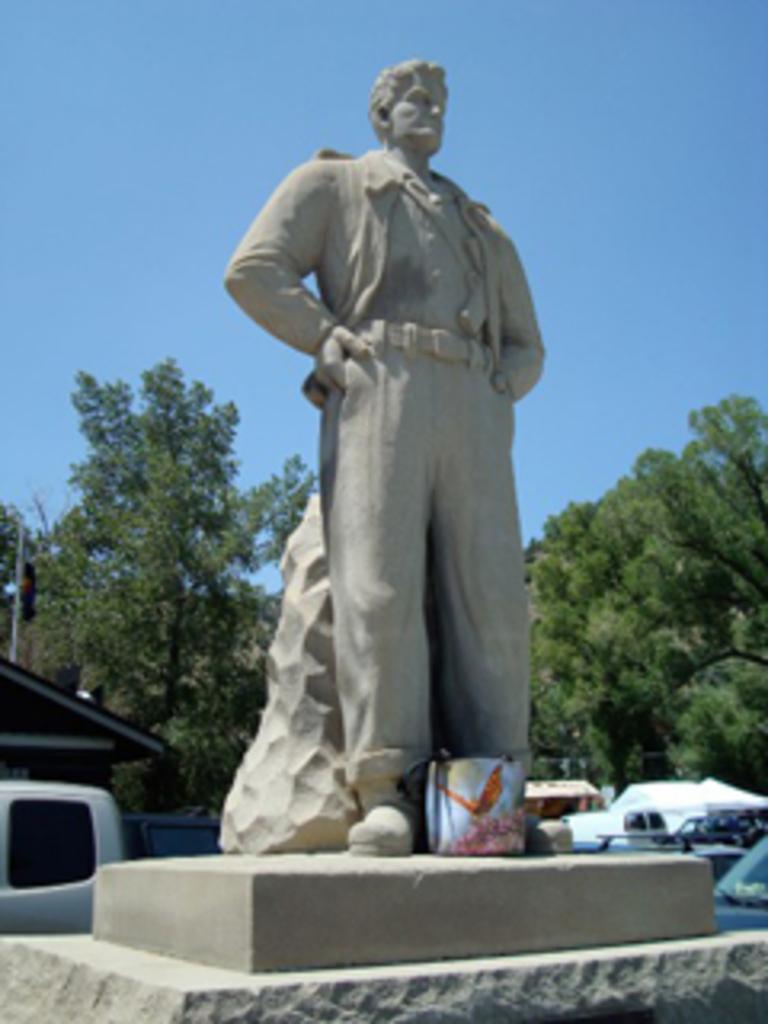Describe this image in one or two sentences. In the image there is a statue of a man and behind the statue there are trees. 